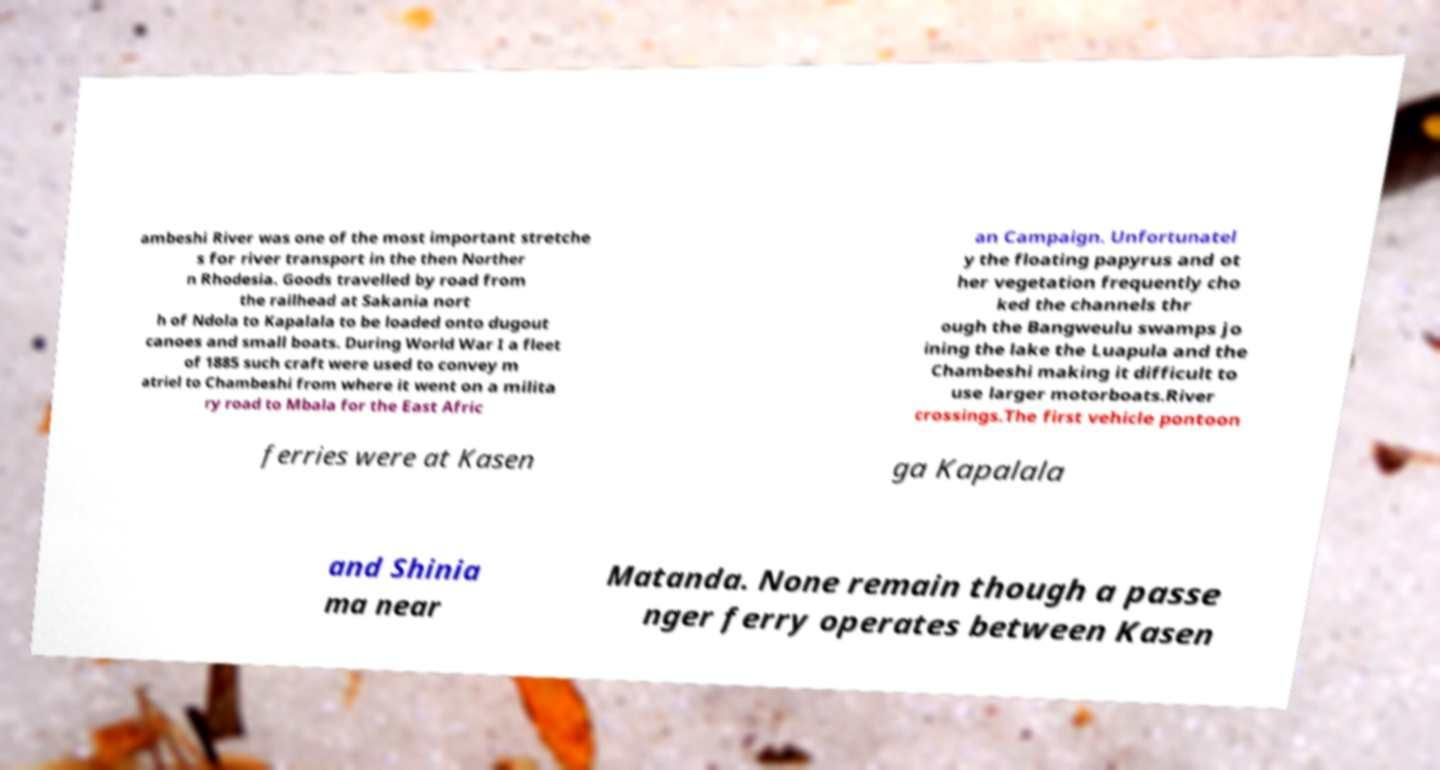For documentation purposes, I need the text within this image transcribed. Could you provide that? ambeshi River was one of the most important stretche s for river transport in the then Norther n Rhodesia. Goods travelled by road from the railhead at Sakania nort h of Ndola to Kapalala to be loaded onto dugout canoes and small boats. During World War I a fleet of 1885 such craft were used to convey m atriel to Chambeshi from where it went on a milita ry road to Mbala for the East Afric an Campaign. Unfortunatel y the floating papyrus and ot her vegetation frequently cho ked the channels thr ough the Bangweulu swamps jo ining the lake the Luapula and the Chambeshi making it difficult to use larger motorboats.River crossings.The first vehicle pontoon ferries were at Kasen ga Kapalala and Shinia ma near Matanda. None remain though a passe nger ferry operates between Kasen 